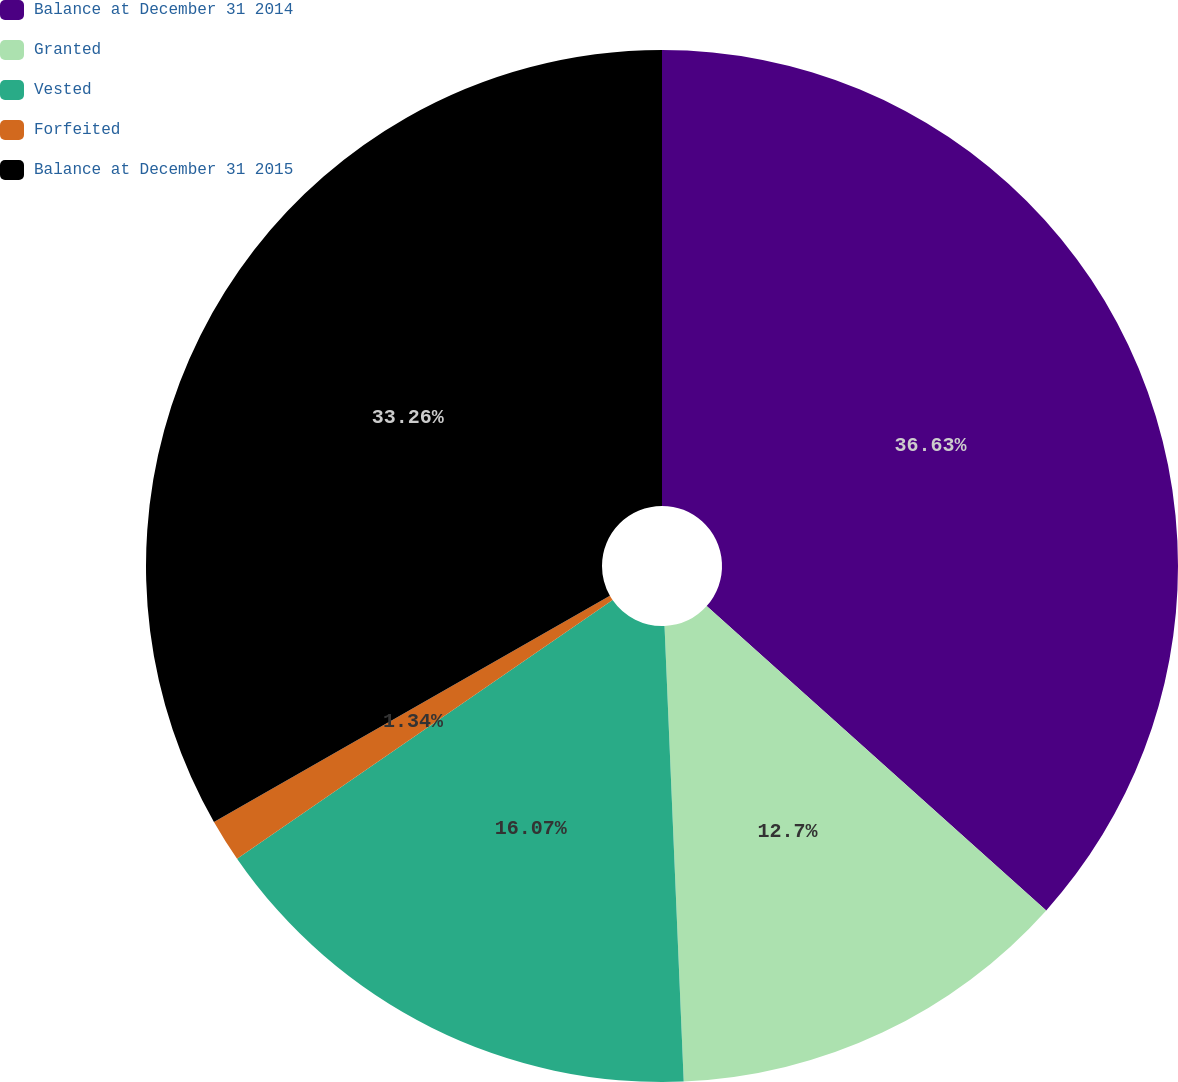Convert chart to OTSL. <chart><loc_0><loc_0><loc_500><loc_500><pie_chart><fcel>Balance at December 31 2014<fcel>Granted<fcel>Vested<fcel>Forfeited<fcel>Balance at December 31 2015<nl><fcel>36.63%<fcel>12.7%<fcel>16.07%<fcel>1.34%<fcel>33.26%<nl></chart> 